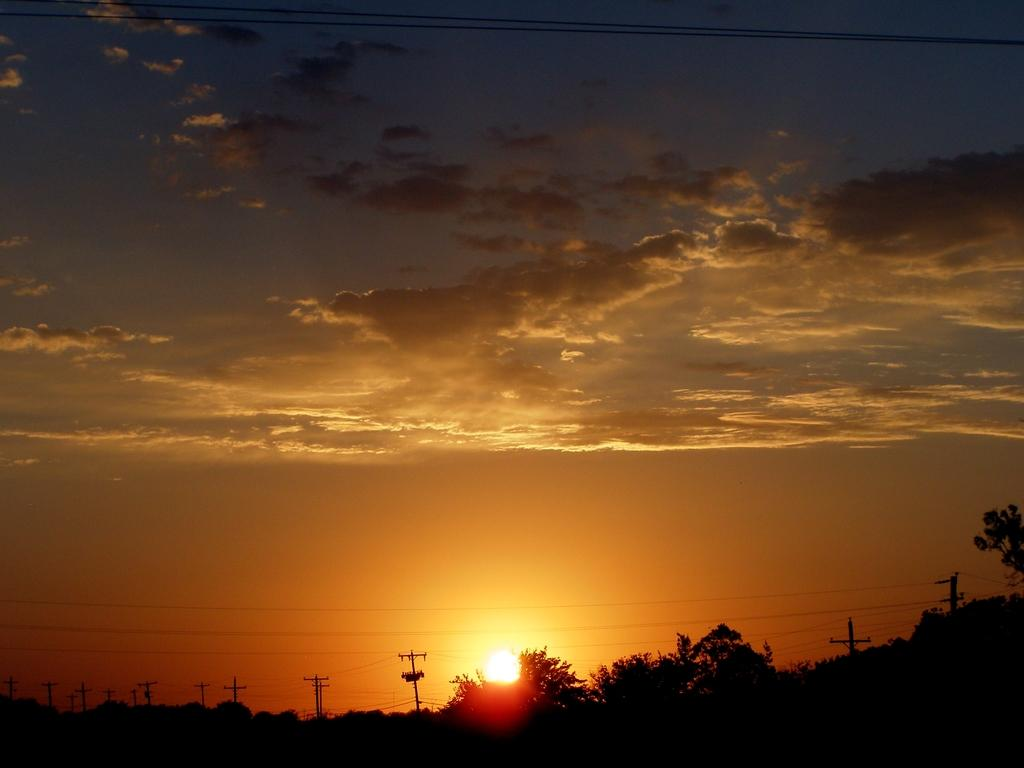What type of natural elements can be seen in the image? There are trees in the image. What man-made structures are present in the image? There are current poles and wires in the image. What can be inferred about the time of day based on the sunlight in the image? The sunlight suggests either a sunrise or a sunset in the image. What is visible in the sky in the image? There are clouds in the sky in the image. What type of clocks can be seen hanging from the trees in the image? There are no clocks present in the image; it features trees, current poles, and wires. Who is the achiever mentioned in the image? There is no mention of an achiever in the image. 